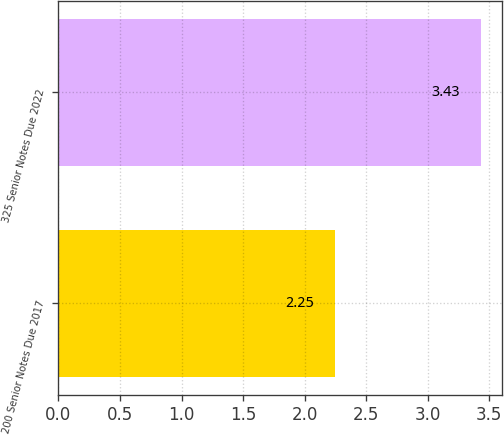<chart> <loc_0><loc_0><loc_500><loc_500><bar_chart><fcel>200 Senior Notes Due 2017<fcel>325 Senior Notes Due 2022<nl><fcel>2.25<fcel>3.43<nl></chart> 